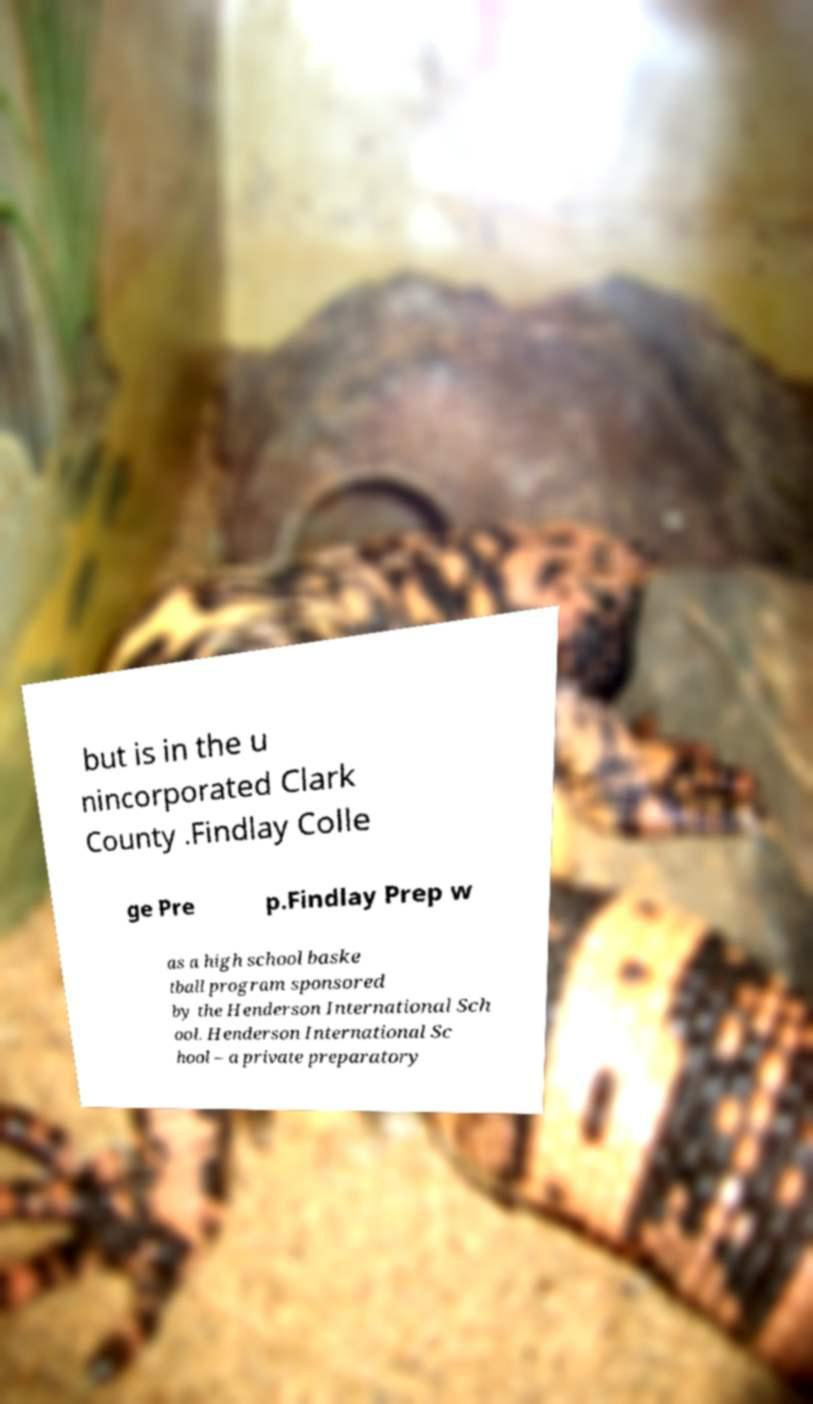What messages or text are displayed in this image? I need them in a readable, typed format. but is in the u nincorporated Clark County .Findlay Colle ge Pre p.Findlay Prep w as a high school baske tball program sponsored by the Henderson International Sch ool. Henderson International Sc hool – a private preparatory 